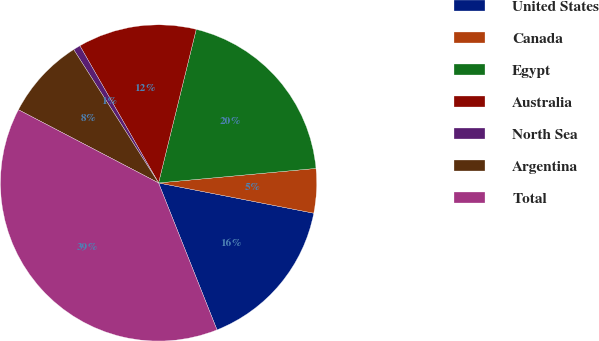Convert chart to OTSL. <chart><loc_0><loc_0><loc_500><loc_500><pie_chart><fcel>United States<fcel>Canada<fcel>Egypt<fcel>Australia<fcel>North Sea<fcel>Argentina<fcel>Total<nl><fcel>15.91%<fcel>4.53%<fcel>19.71%<fcel>12.12%<fcel>0.73%<fcel>8.32%<fcel>38.69%<nl></chart> 